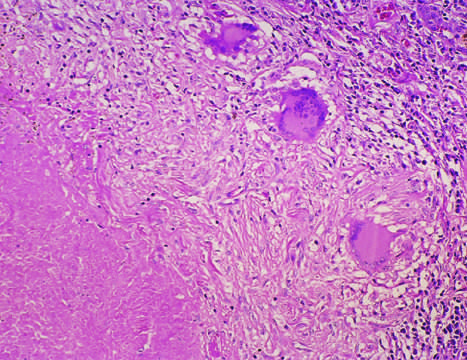what does a characteristic tubercle at low magnification show?
Answer the question using a single word or phrase. Central granular caseation 